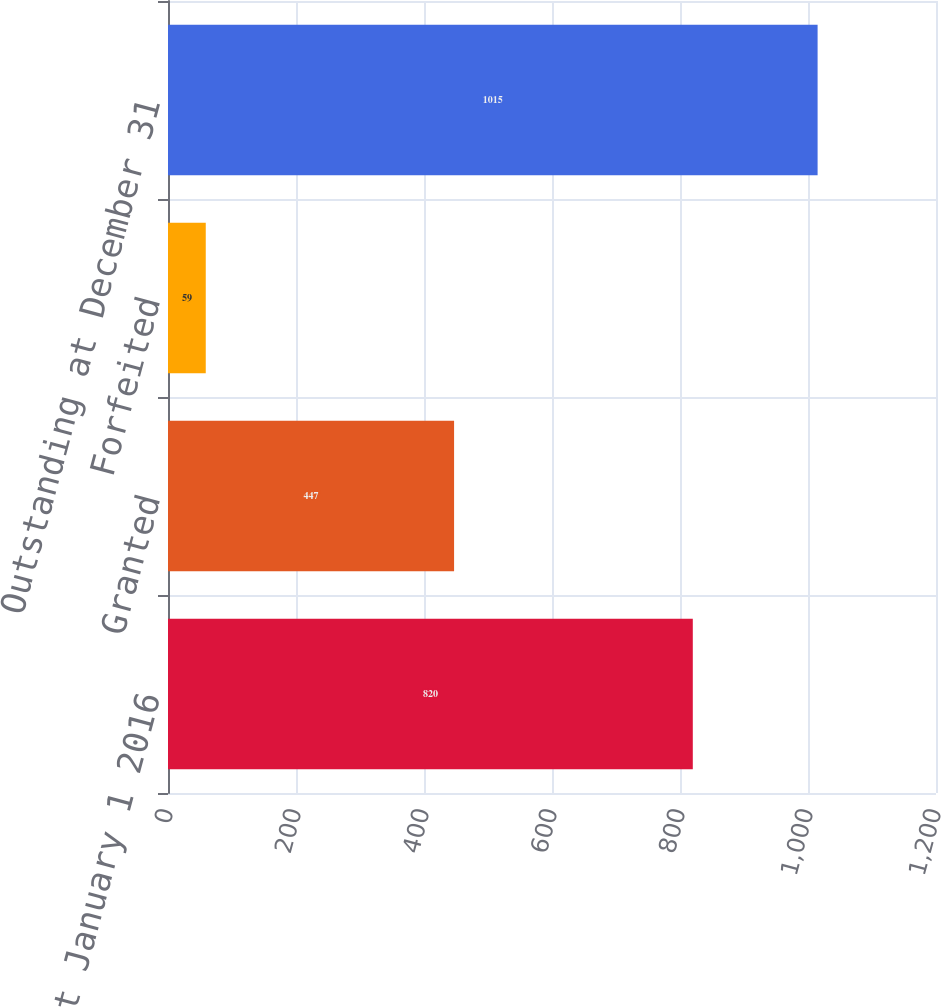<chart> <loc_0><loc_0><loc_500><loc_500><bar_chart><fcel>Outstanding at January 1 2016<fcel>Granted<fcel>Forfeited<fcel>Outstanding at December 31<nl><fcel>820<fcel>447<fcel>59<fcel>1015<nl></chart> 